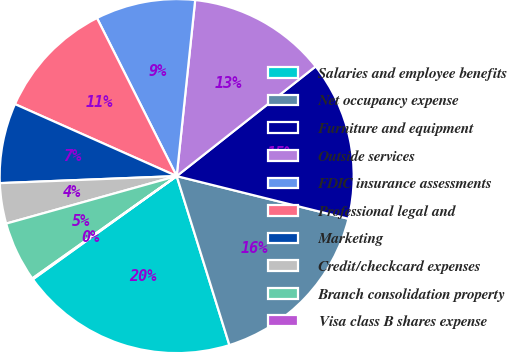<chart> <loc_0><loc_0><loc_500><loc_500><pie_chart><fcel>Salaries and employee benefits<fcel>Net occupancy expense<fcel>Furniture and equipment<fcel>Outside services<fcel>FDIC insurance assessments<fcel>Professional legal and<fcel>Marketing<fcel>Credit/checkcard expenses<fcel>Branch consolidation property<fcel>Visa class B shares expense<nl><fcel>19.91%<fcel>16.31%<fcel>14.51%<fcel>12.7%<fcel>9.1%<fcel>10.9%<fcel>7.3%<fcel>3.69%<fcel>5.49%<fcel>0.09%<nl></chart> 